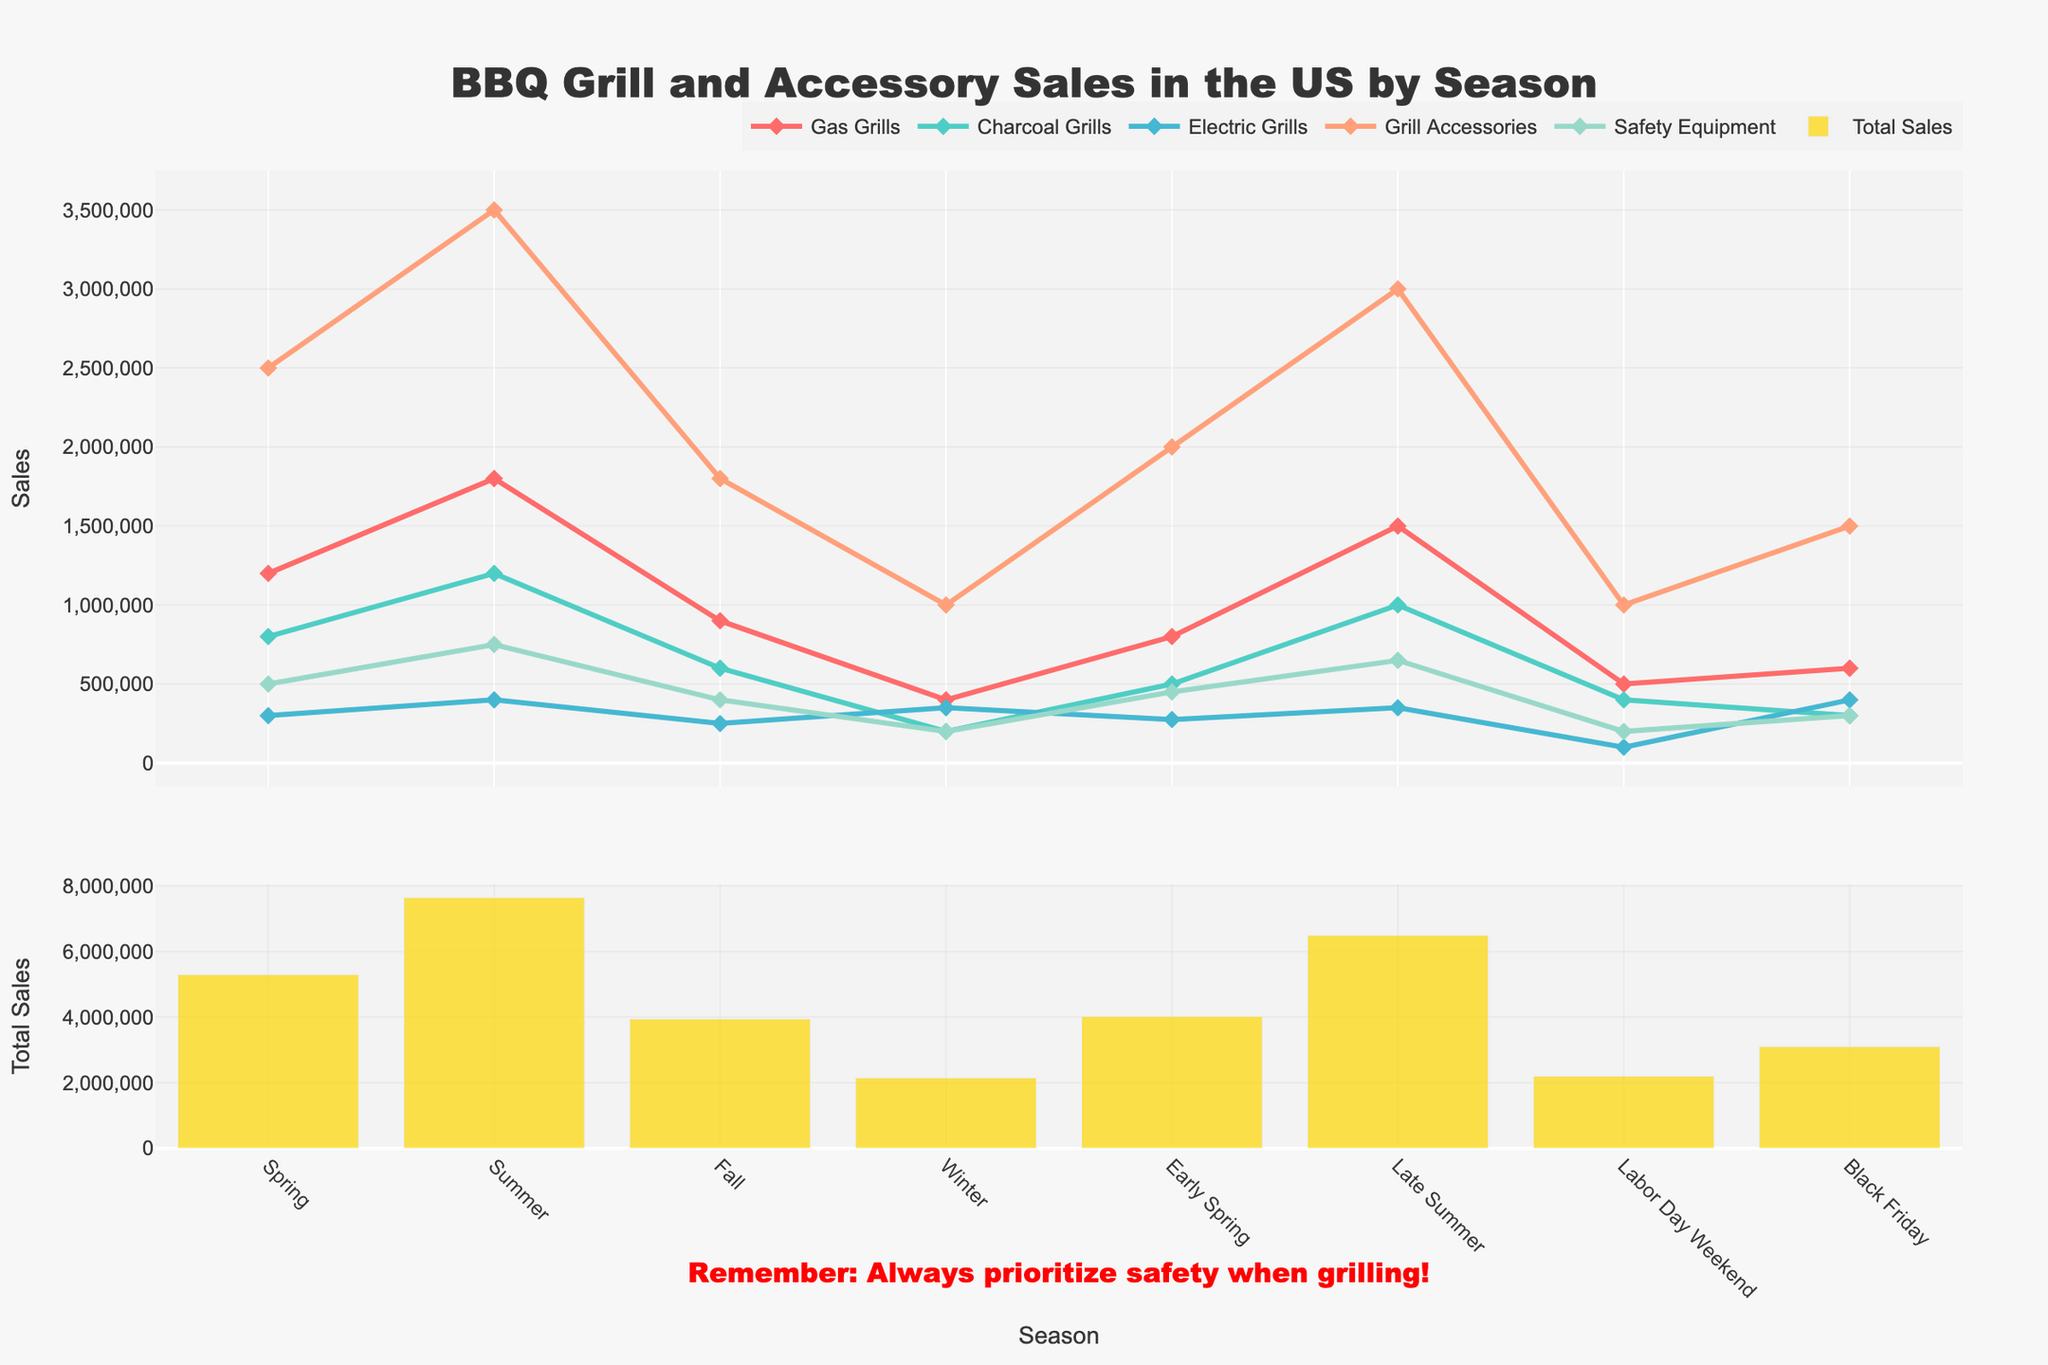What's the highest sales figure for any item across all seasons? The highest sales figure is for Grill Accessories during Summer. We look at each category's sales during each season and compare the numbers. Grill Accessories during Summer have the highest sales at 3,500,000.
Answer: 3,500,000 Which season has the highest total sales of all items combined? We examine the bar heights in the lower chart representing total sales. Summer has the tallest bar, indicating the highest total sales.
Answer: Summer How many more Gas Grills were sold in Summer compared to Winter? To find this, we subtract the sales of Gas Grills in Winter from those in Summer: 1,800,000 (Summer) - 400,000 (Winter). The result is 1,400,000 more Gas Grills sold in Summer.
Answer: 1,400,000 In which season did Charcoal Grills sales match Safety Equipment sales? We need to find when the sales of Charcoal Grills equal those of Safety Equipment by visually comparing their values across seasons. For Black Friday, both are 300,000.
Answer: Black Friday What was the average sale of Electric Grills over all the seasons? We sum the sales of Electric Grills for all seasons and then divide by the number of seasons: (300,000 + 400,000 + 250,000 + 350,000 + 275,000 + 350,000 + 100,000 + 400,000) / 8. The total is 2,425,000, and the average is 2,425,000 / 8 = 303,125.
Answer: 303,125 Which item sees the most substantial drop in sales from Summer to Fall? We calculate the difference between Summer and Fall sales for each item and identify the largest decrease. Charcoal Grills drop from 1,200,000 (Summer) to 600,000 (Fall), which is a decrease of 600,000, the largest drop among items.
Answer: Charcoal Grills In which season is the sum of Gas Grills and Charcoal Grills sales the lowest? We sum the sales of Gas Grills and Charcoal Grills for each season and compare them: Spring (2,000,000), Summer (3,000,000), Fall (1,500,000), Winter (600,000), Early Spring (1,300,000), Late Summer (2,500,000), Labor Day Weekend (900,000), Black Friday (900,000). Winter has the lowest sum of 600,000.
Answer: Winter What is the combined sales of Grill Accessories in Spring and Early Spring? We add the sales of Grill Accessories for Spring and Early Spring: 2,500,000 (Spring) + 2,000,000 (Early Spring) = 4,500,000.
Answer: 4,500,000 During which season are Electric Grills sales higher than Charcoal Grills sales? By comparing the sales figures of Electric Grills and Charcoal Grills across seasons, we find that in Winter and Black Friday, Electric Grills sales (350,000 and 400,000) exceed Charcoal Grills sales (200,000 and 300,000).
Answer: Winter and Black Friday 